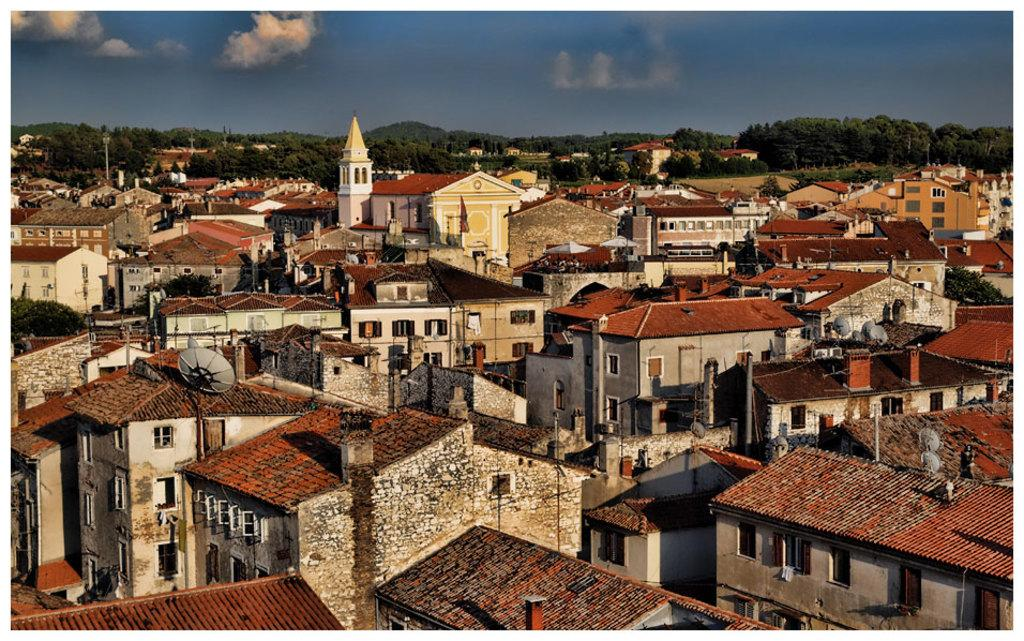What type of buildings can be seen in the image? There are houses in the image. Is there any other significant structure in the image? Yes, there is a church in the image. How is the church positioned in relation to the houses? The church is located between the houses. What can be seen in the background of the image? There are trees and mountains in the background of the image. What type of glue is being used to hold the church together in the image? There is no indication of glue or any construction materials in the image; it is a representation of a church and houses. Can you see the engine of the church in the image? Churches do not have engines, as they are not vehicles. The image shows a church building, not a functioning engine. 